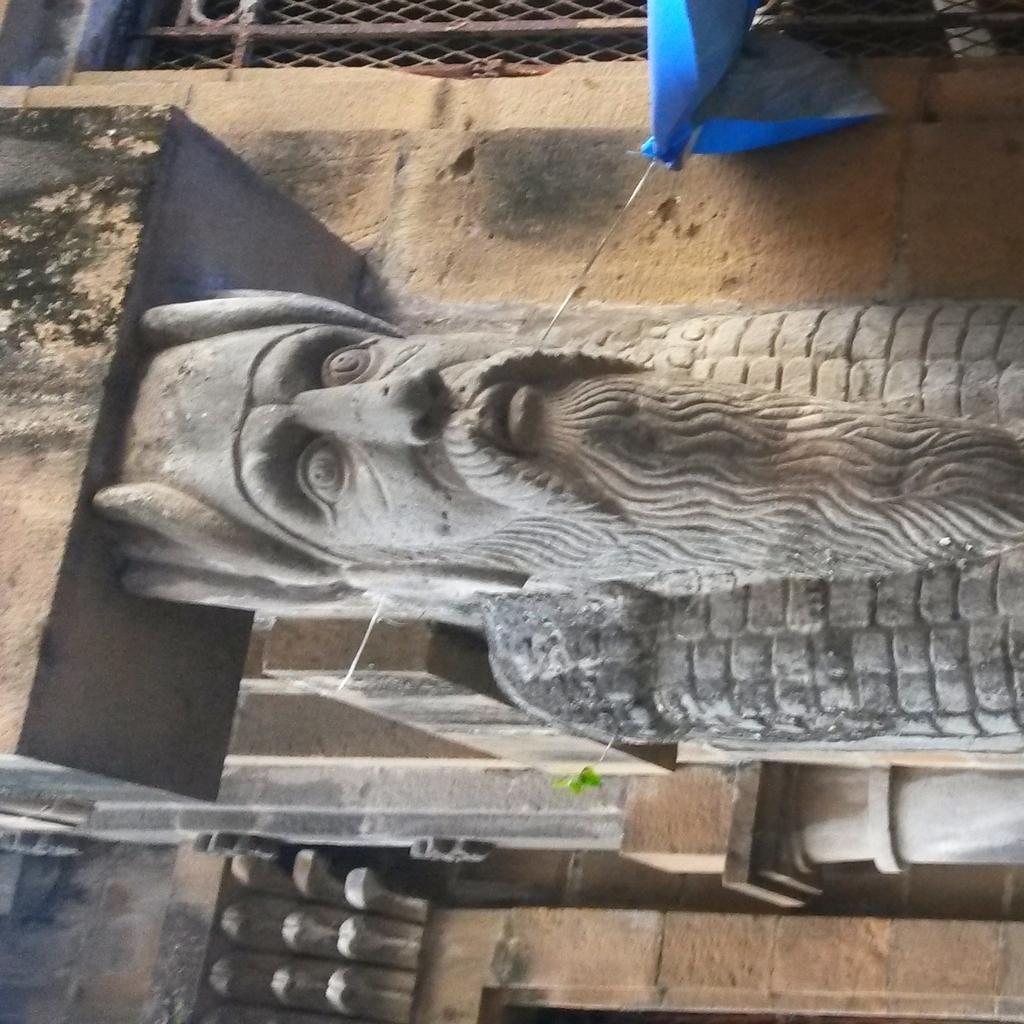How would you summarize this image in a sentence or two? In the center of the image there is a statue. Behind the statue there is a building. On the right side of the image there is a cover tied to the wire. There is a metal fence. 